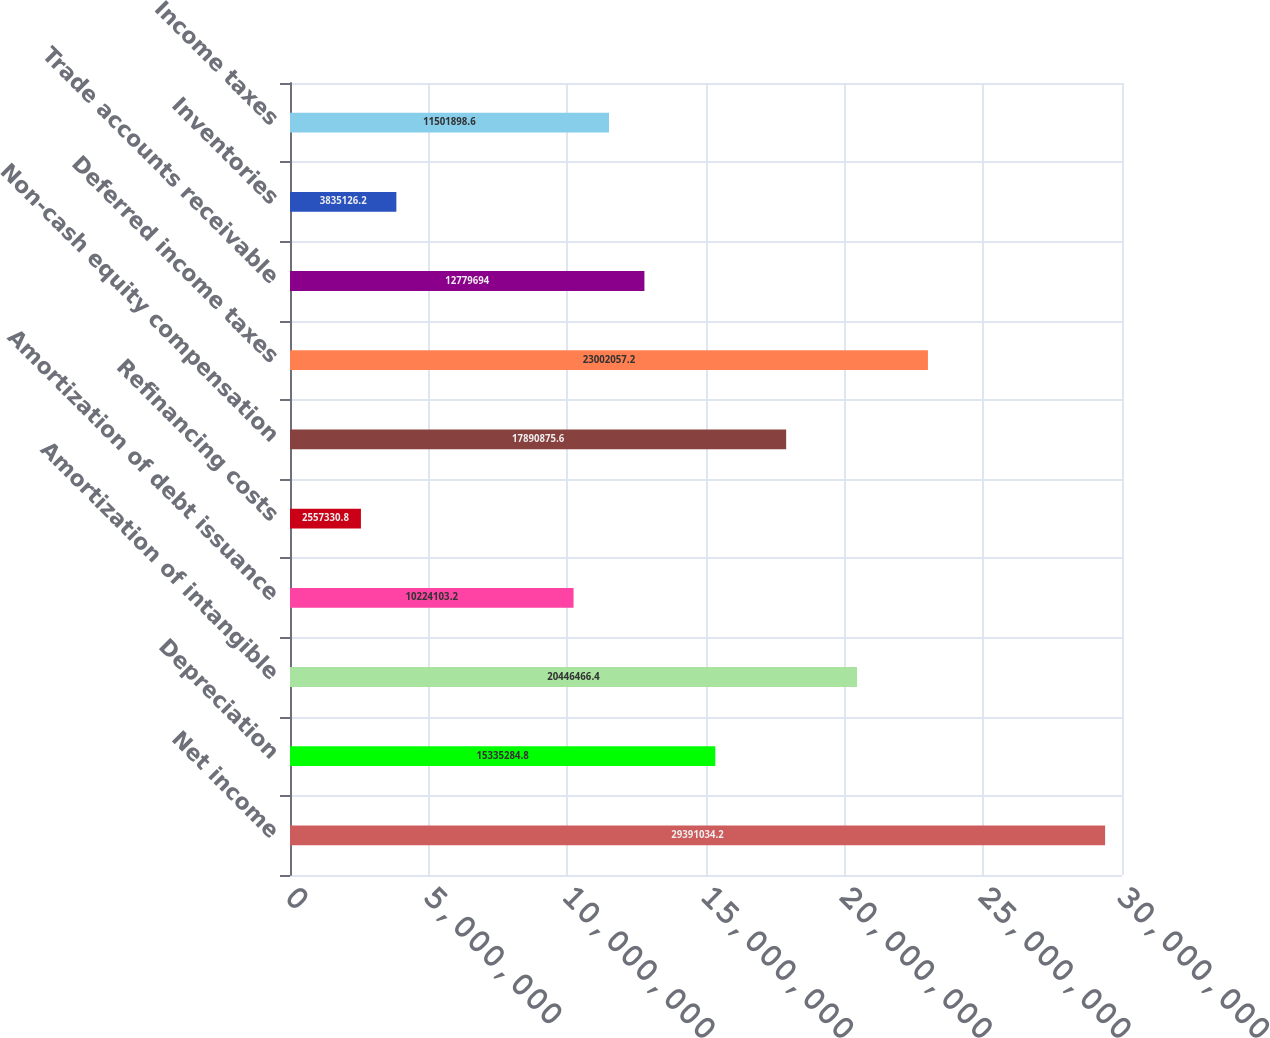Convert chart to OTSL. <chart><loc_0><loc_0><loc_500><loc_500><bar_chart><fcel>Net income<fcel>Depreciation<fcel>Amortization of intangible<fcel>Amortization of debt issuance<fcel>Refinancing costs<fcel>Non-cash equity compensation<fcel>Deferred income taxes<fcel>Trade accounts receivable<fcel>Inventories<fcel>Income taxes<nl><fcel>2.9391e+07<fcel>1.53353e+07<fcel>2.04465e+07<fcel>1.02241e+07<fcel>2.55733e+06<fcel>1.78909e+07<fcel>2.30021e+07<fcel>1.27797e+07<fcel>3.83513e+06<fcel>1.15019e+07<nl></chart> 